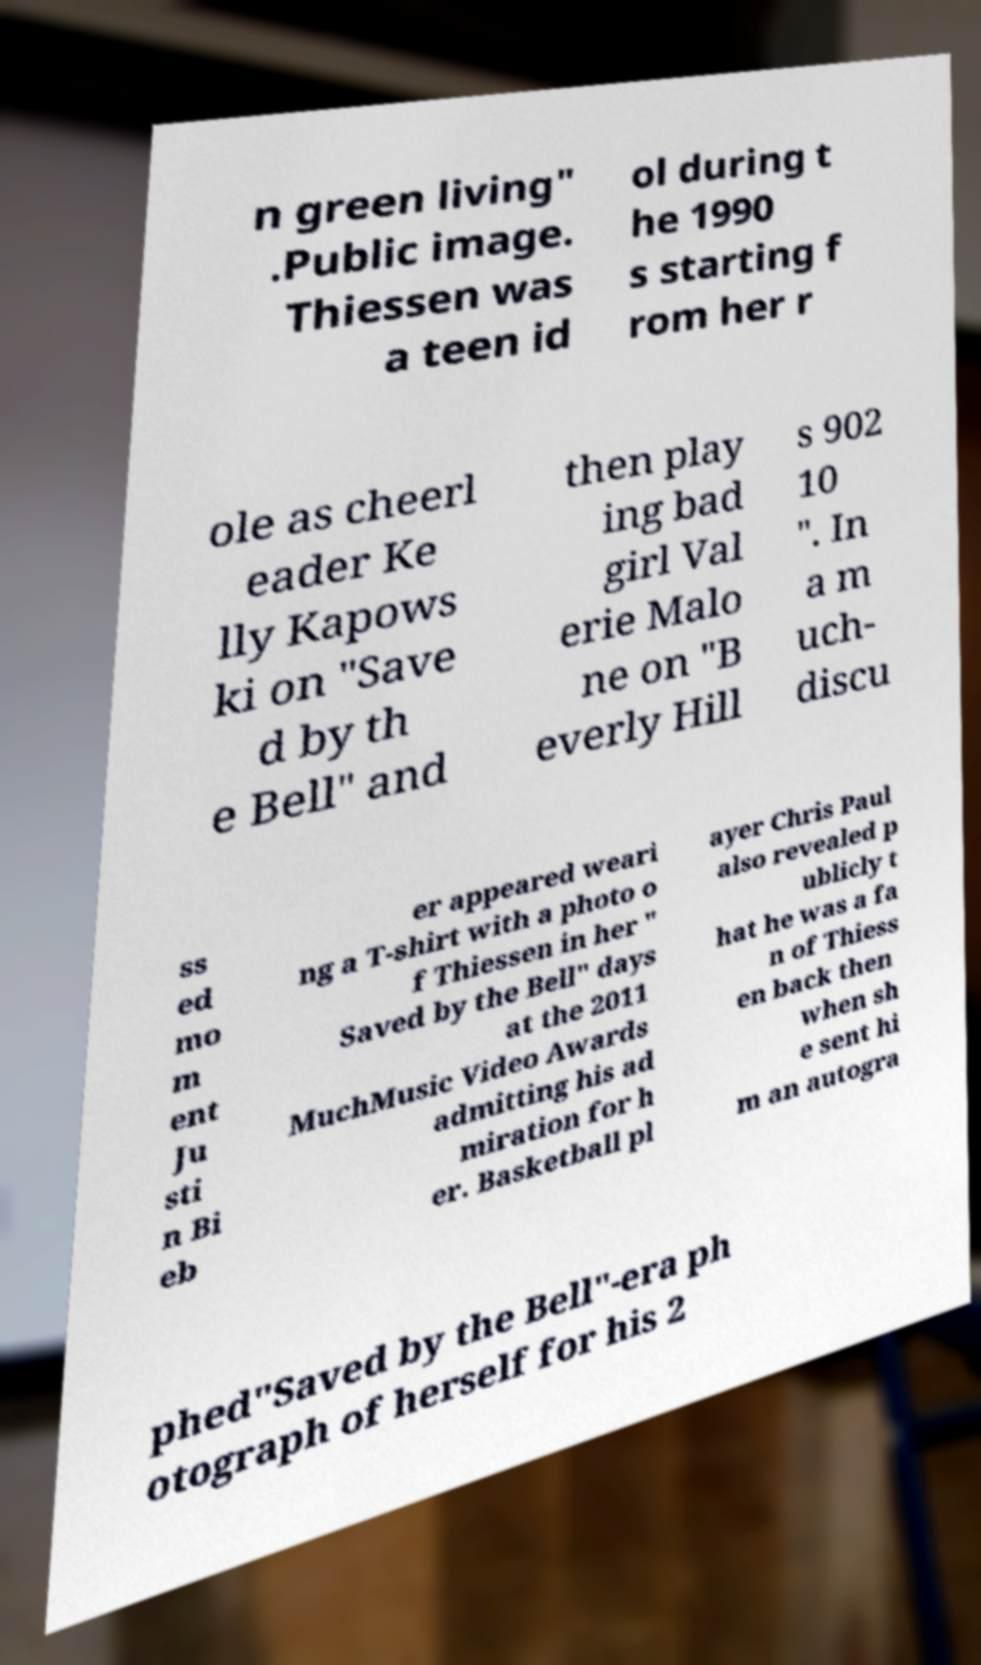There's text embedded in this image that I need extracted. Can you transcribe it verbatim? n green living" .Public image. Thiessen was a teen id ol during t he 1990 s starting f rom her r ole as cheerl eader Ke lly Kapows ki on "Save d by th e Bell" and then play ing bad girl Val erie Malo ne on "B everly Hill s 902 10 ". In a m uch- discu ss ed mo m ent Ju sti n Bi eb er appeared weari ng a T-shirt with a photo o f Thiessen in her " Saved by the Bell" days at the 2011 MuchMusic Video Awards admitting his ad miration for h er. Basketball pl ayer Chris Paul also revealed p ublicly t hat he was a fa n of Thiess en back then when sh e sent hi m an autogra phed"Saved by the Bell"-era ph otograph of herself for his 2 